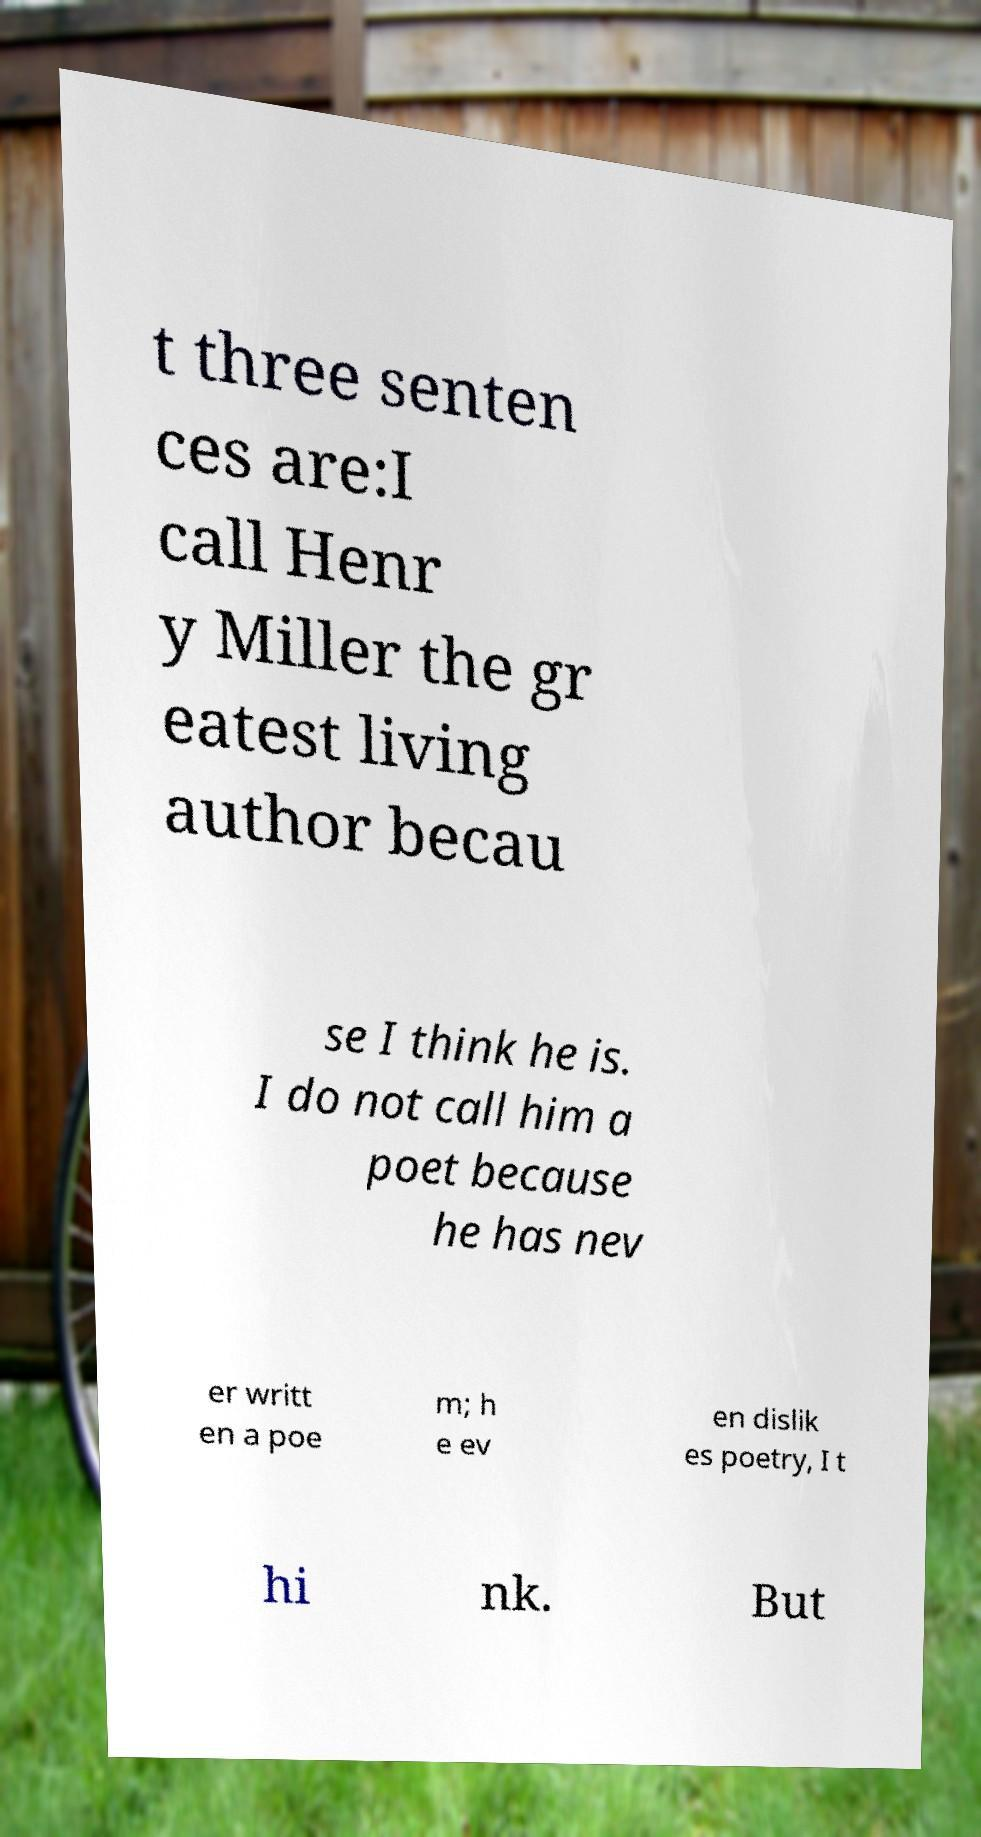Can you accurately transcribe the text from the provided image for me? t three senten ces are:I call Henr y Miller the gr eatest living author becau se I think he is. I do not call him a poet because he has nev er writt en a poe m; h e ev en dislik es poetry, I t hi nk. But 